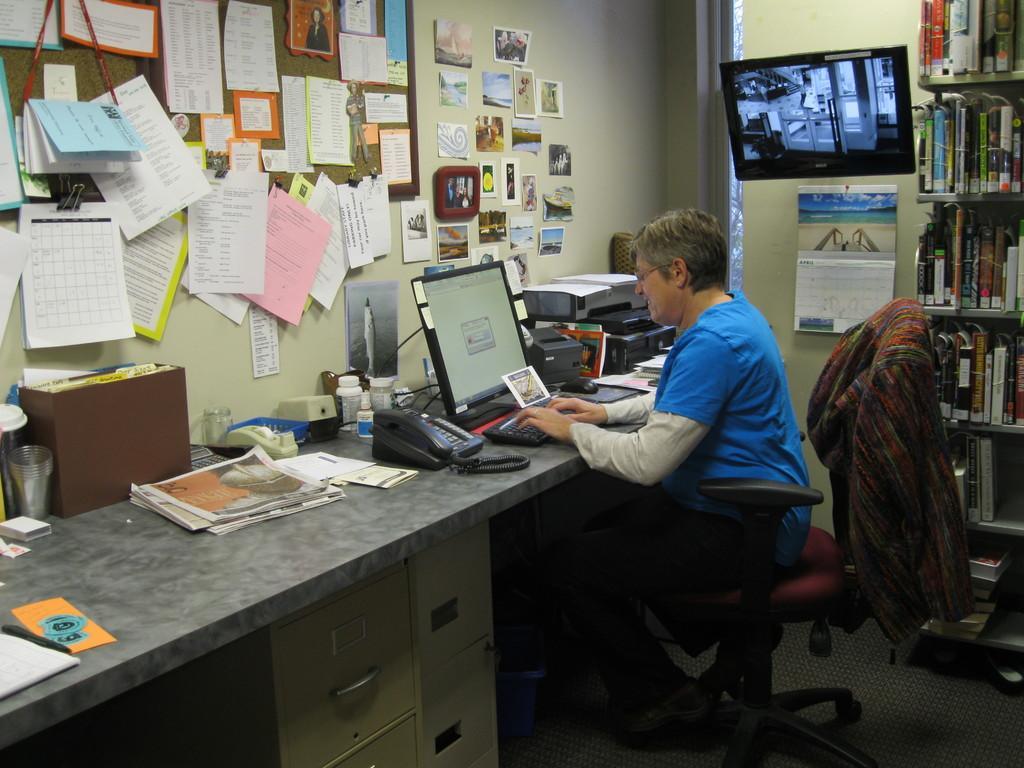In one or two sentences, can you explain what this image depicts? The image is inside the room. In the image there is a person sitting on chair in front of a table, on table we can see a keyboard,monitor,land mobile,printer,news papers,papers,bottle,glass,box,card,mouse. On right side there is a television,calendar,shelf on shelf we can also see some books. On left side there is a wall which is in cream color,papers,board and a window which is closed. 